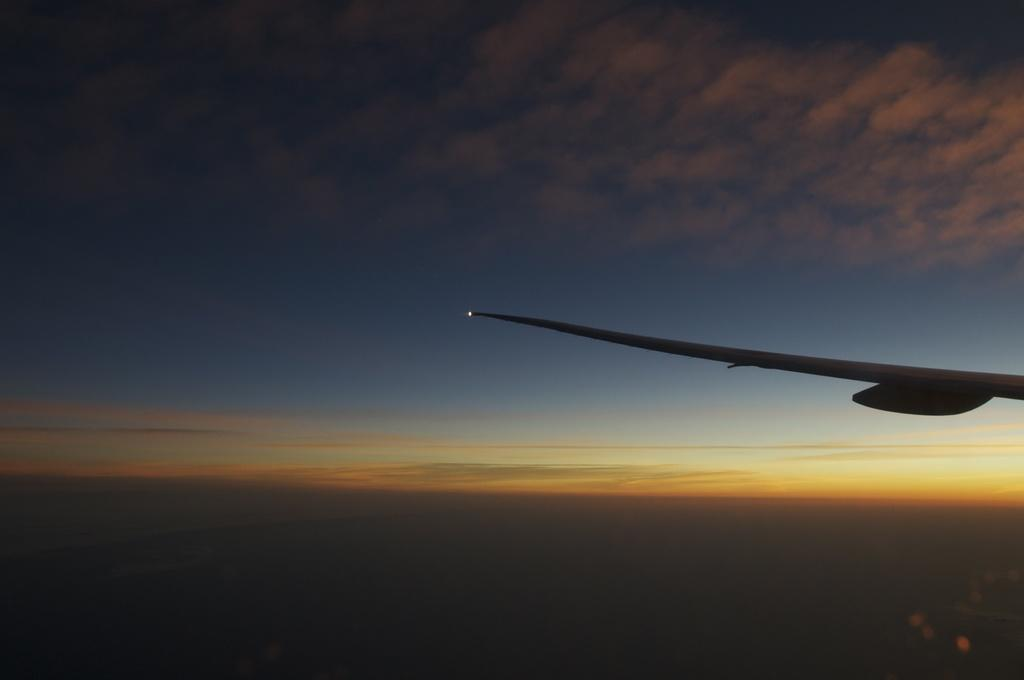What is the main subject of the image? The main subject of the image is a wing of an airplane. Where is the wing located in the image? The wing is in the sky. What type of linen is being used to rest on during the flight in the image? There is no linen or flight depicted in the image; it only shows a wing of an airplane in the sky. 